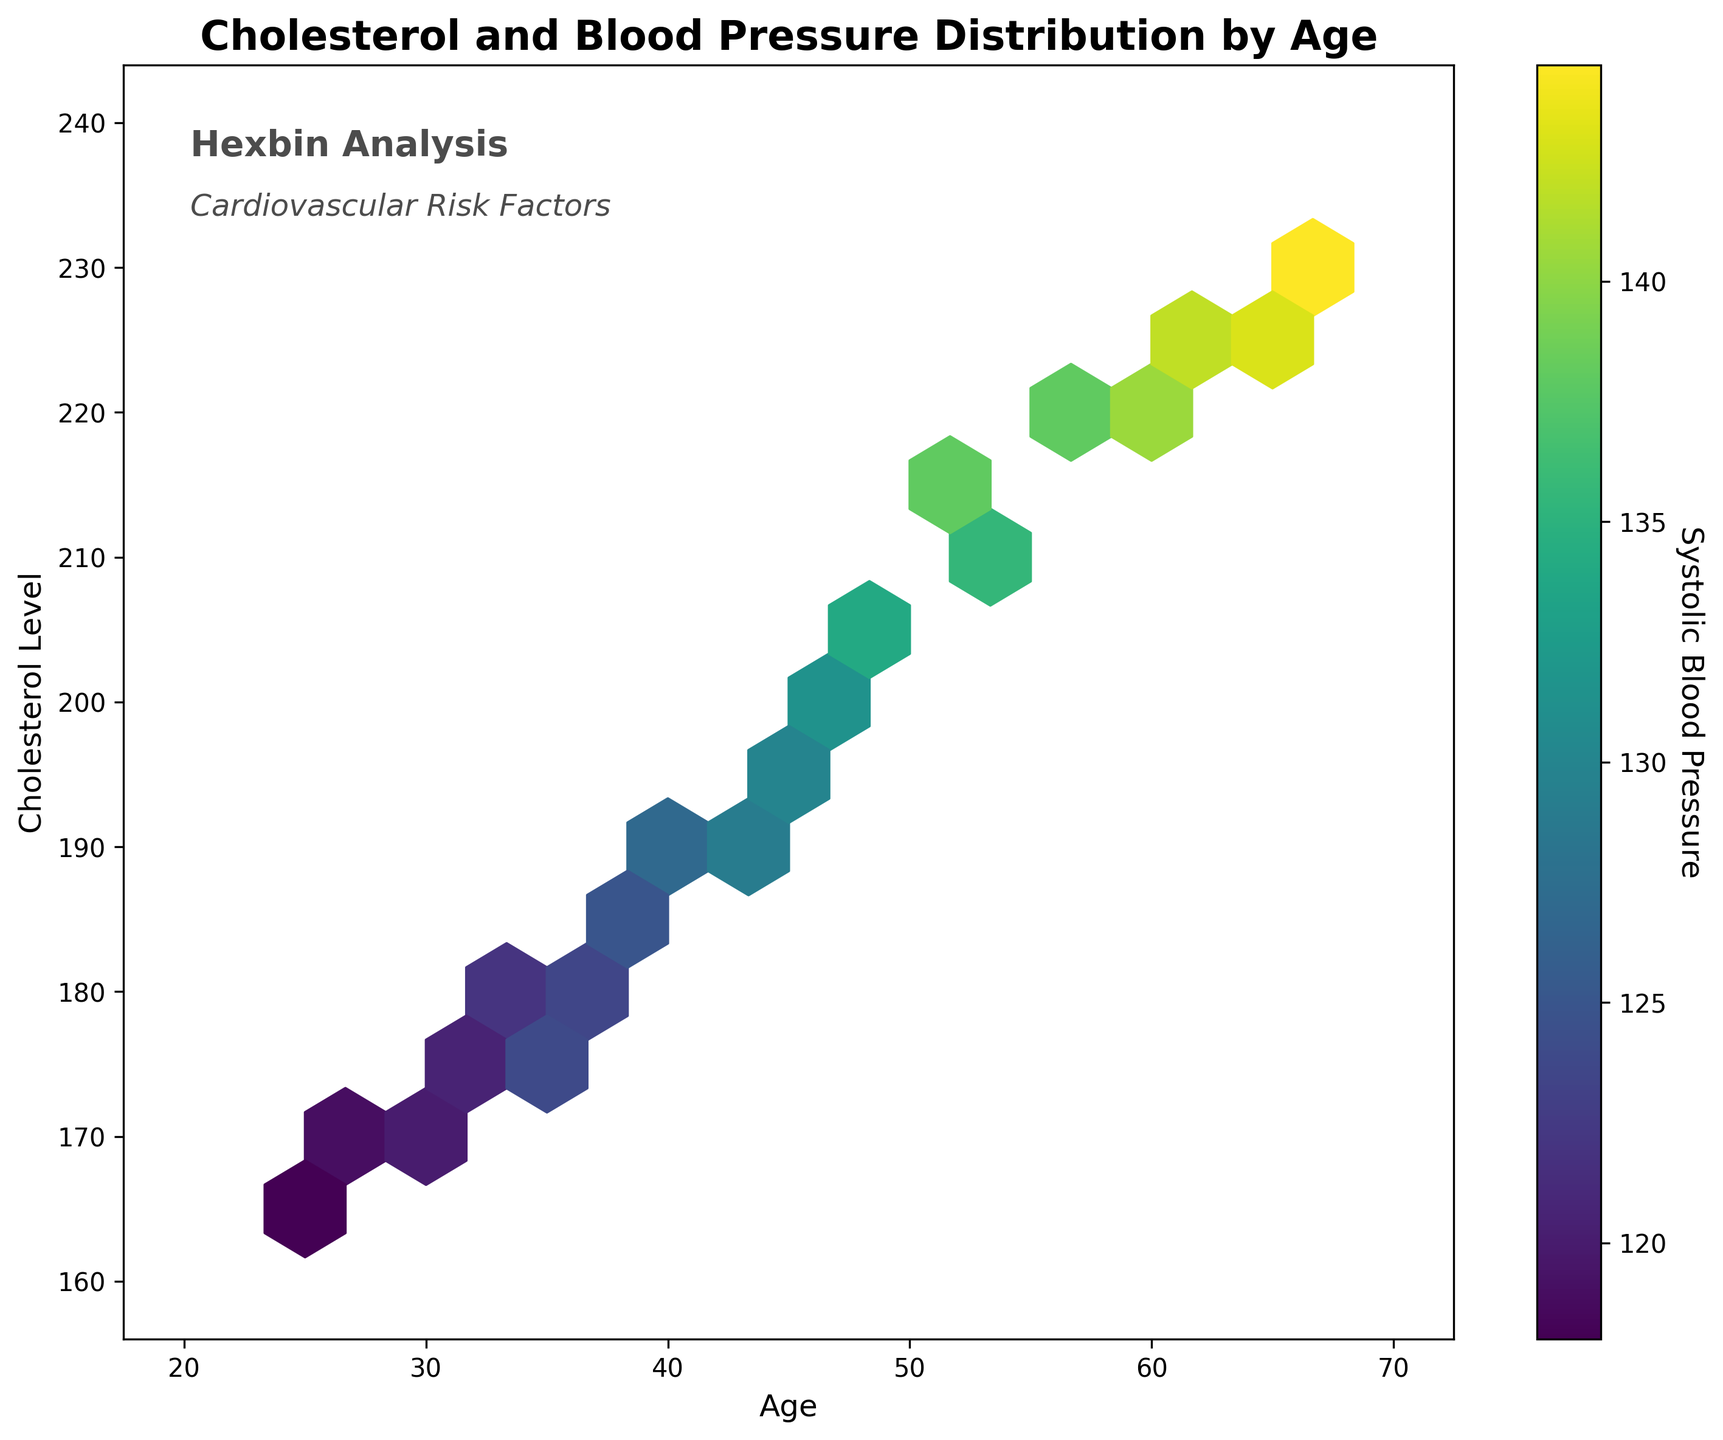What's the title of the figure? The title is generally at the top of the plot. In this plot, it reads "Cholesterol and Blood Pressure Distribution by Age."
Answer: Cholesterol and Blood Pressure Distribution by Age What does the colorbar represent? A colorbar is a visual representation of the values associated with colors in the plot. Here, it is labeled "Systolic Blood Pressure," indicating it represents systolic blood pressure levels.
Answer: Systolic Blood Pressure In what age range do cholesterol levels exceed 210 mg/dL? Observe the age values for points where the cholesterol level (y-axis) is above 210 mg/dL. In the plot, this seems to start from about 55 years old onwards.
Answer: 55 years and older What is the range of systolic blood pressure values depicted in the plot? The colorbar on the side of the plot provides this information. It ranges from around 120 to 145 mmHg.
Answer: 120 to 145 mmHg Does the density of points suggest a trend between age and cholesterol levels? The density of points shows how often certain combinations occur. Here, higher densities appear as the age increases from around 30 to 60 years, suggesting that cholesterol levels tend to increase with age.
Answer: Cholesterol levels tend to increase with age At approximately what age range does the plot show the highest cholesterol levels? By observing the vertical spread of points, the highest cholesterol levels (between 220 and 240) are in the range of about 60 to 70 years old.
Answer: 60 to 70 years old Is there a clear correlation between age and systolic blood pressure levels? The color-coding indicates higher systolic blood pressure with higher cholesterol and age. The bright colors (indicating higher pressures) are more prevalent in older age groups.
Answer: Positive correlation Which age group seems to have the lowest range of cholesterol levels? Looking at the hexbin plot, the lighter colors (indicative of lower cholesterol levels) tend to cluster around the younger age groups, particularly from 25 to 35 years.
Answer: 25 to 35 years How is the data most densely packed in terms of age? The most densely packed area indicates where the data points (hexbins) are densest. This appears to be around the age range of 40 to 60 years.
Answer: 40 to 60 years What are the mean and median cholesterol levels for the age group 50-60 years? To calculate the mean and median, we need to manually extract relevant data points (50,205; 52,215; 53,212; 57,218; 58,219) and compute the mean (215) and median (215).
Answer: Mean: 215 mg/dL, Median: 215 mg/dL 